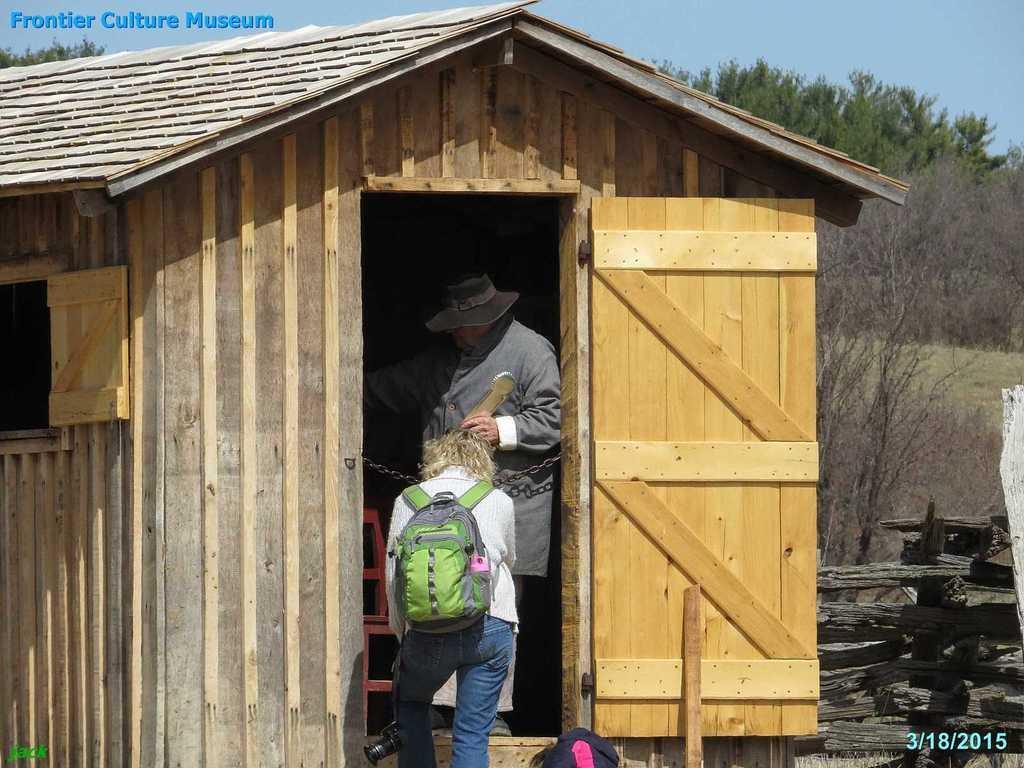Could you give a brief overview of what you see in this image? As we can see in the image there is a sky, trees, wooden house and two people over here. 